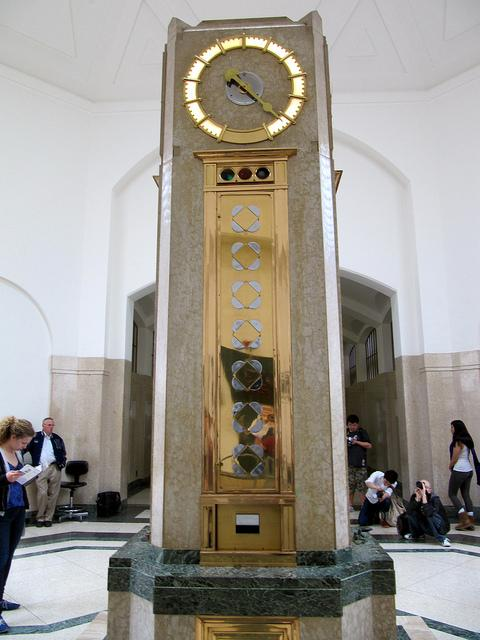The hand of the clock is closest to what number? five 